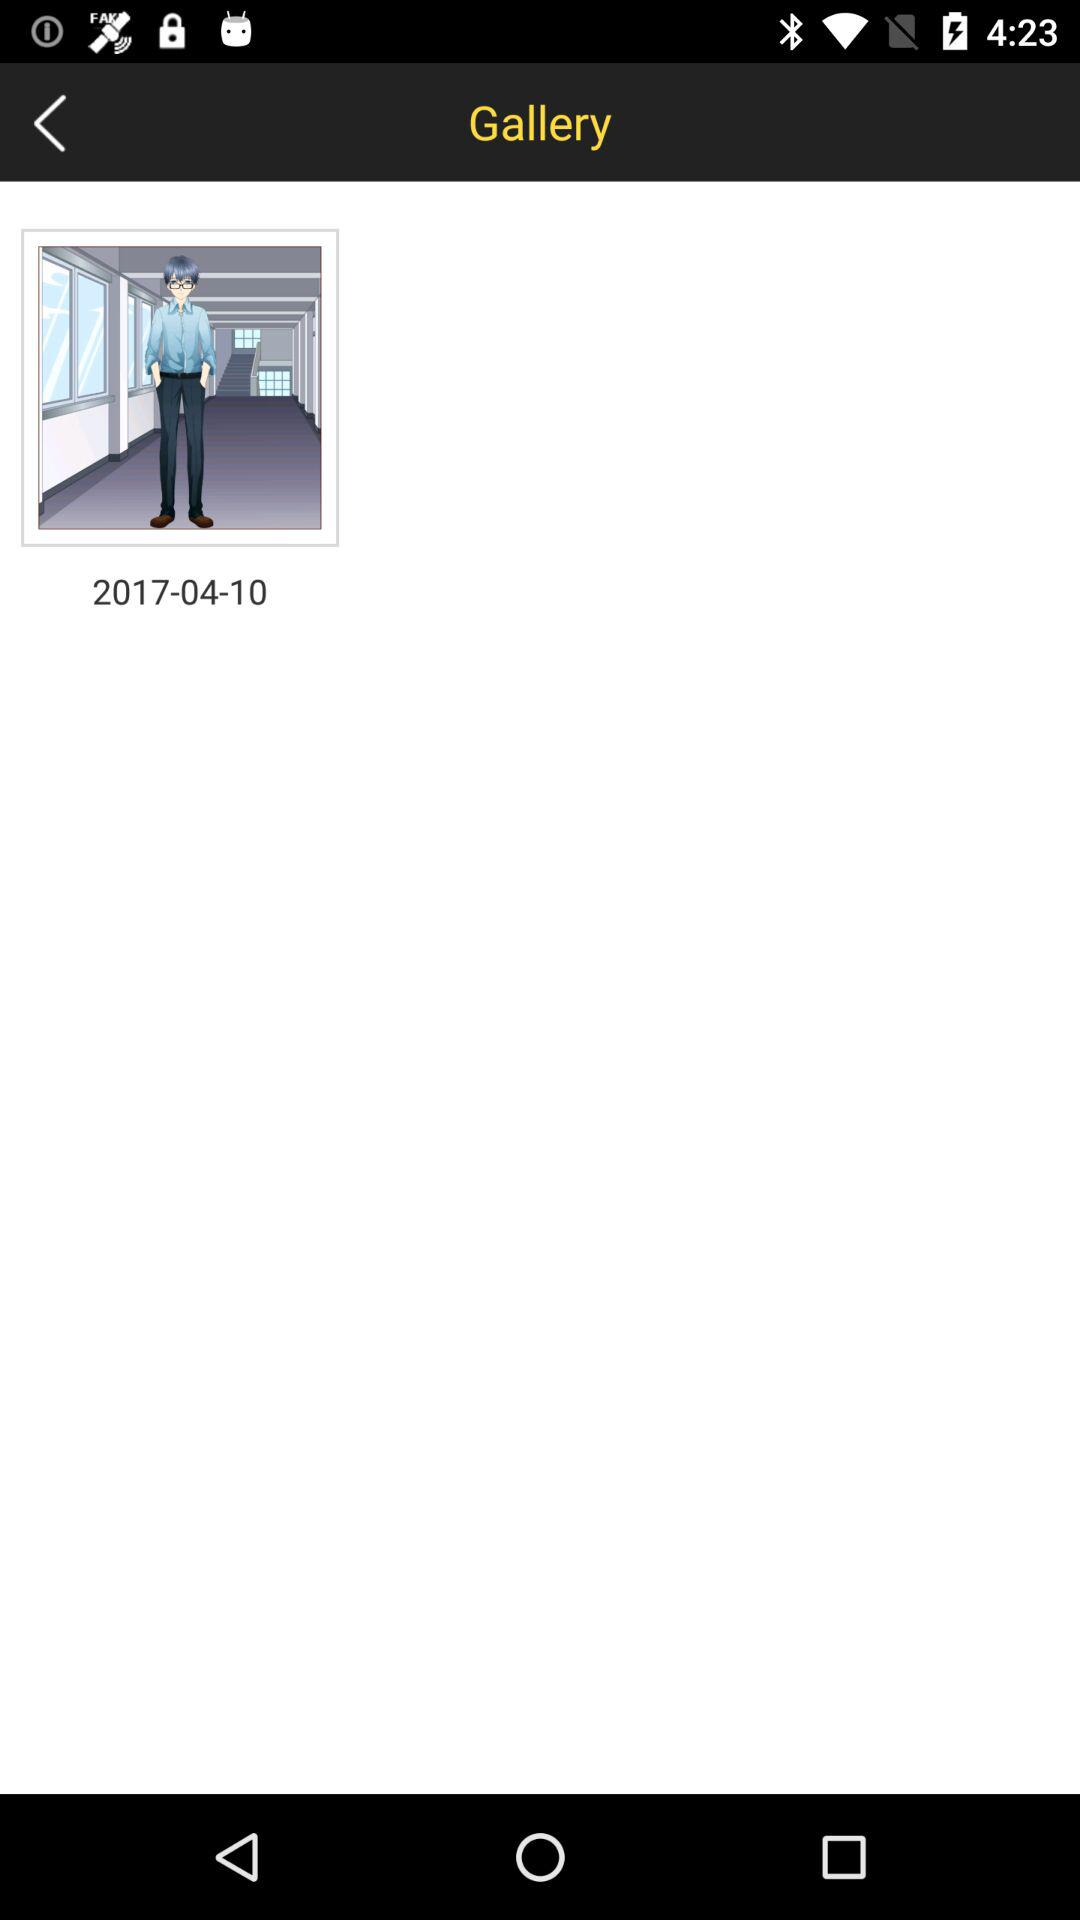On what date is the image saved in the gallery? The date is 2017-04-10. 